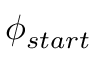<formula> <loc_0><loc_0><loc_500><loc_500>\phi _ { s t a r t }</formula> 